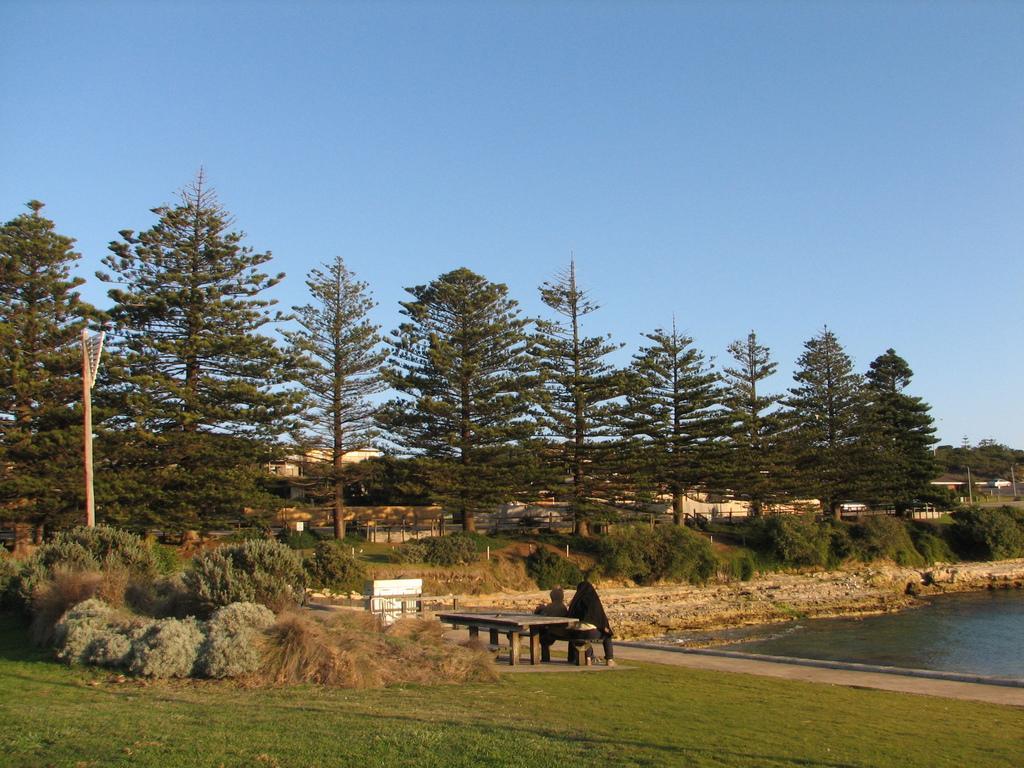Could you give a brief overview of what you see in this image? In the image there are two persons sitting on bench on grassland, on the right side there is a pond and in the back there are trees all over the place and above its sky. 